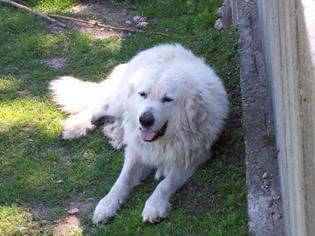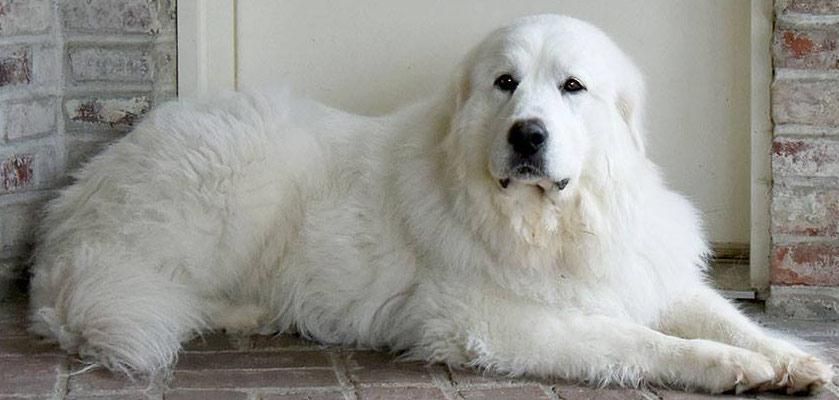The first image is the image on the left, the second image is the image on the right. Evaluate the accuracy of this statement regarding the images: "There are more animals in the image on the right.". Is it true? Answer yes or no. No. The first image is the image on the left, the second image is the image on the right. Considering the images on both sides, is "A white furry dog is in front of a group of sheep." valid? Answer yes or no. No. 